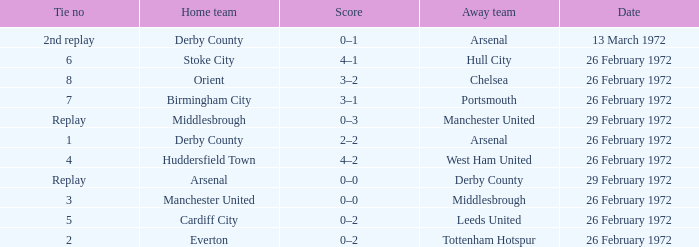Which Tie is from everton? 2.0. 